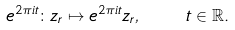Convert formula to latex. <formula><loc_0><loc_0><loc_500><loc_500>e ^ { 2 \pi i t } \colon z _ { r } \mapsto e ^ { 2 \pi i t } z _ { r } , \quad t \in \mathbb { R } .</formula> 